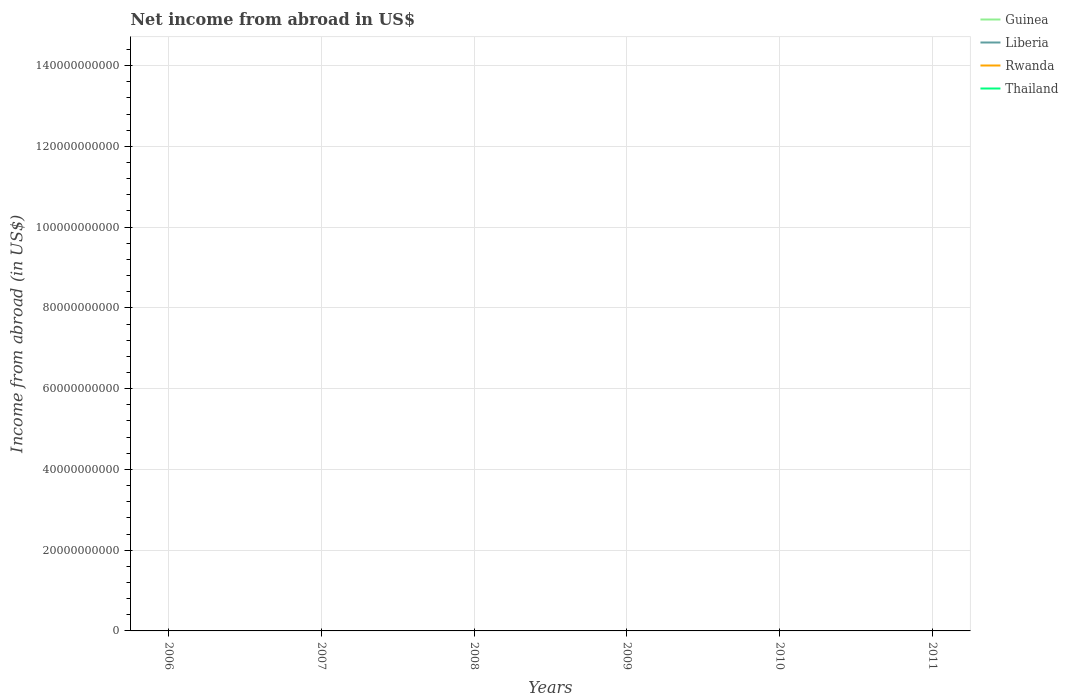How many different coloured lines are there?
Offer a terse response. 0. Does the line corresponding to Rwanda intersect with the line corresponding to Thailand?
Offer a very short reply. No. Is the number of lines equal to the number of legend labels?
Give a very brief answer. No. Across all years, what is the maximum net income from abroad in Thailand?
Offer a terse response. 0. Is the net income from abroad in Liberia strictly greater than the net income from abroad in Rwanda over the years?
Offer a terse response. No. What is the difference between two consecutive major ticks on the Y-axis?
Provide a short and direct response. 2.00e+1. Are the values on the major ticks of Y-axis written in scientific E-notation?
Your answer should be very brief. No. Where does the legend appear in the graph?
Make the answer very short. Top right. What is the title of the graph?
Ensure brevity in your answer.  Net income from abroad in US$. Does "Bahamas" appear as one of the legend labels in the graph?
Provide a succinct answer. No. What is the label or title of the X-axis?
Your response must be concise. Years. What is the label or title of the Y-axis?
Offer a terse response. Income from abroad (in US$). What is the Income from abroad (in US$) in Guinea in 2006?
Your answer should be very brief. 0. What is the Income from abroad (in US$) in Liberia in 2007?
Keep it short and to the point. 0. What is the Income from abroad (in US$) in Rwanda in 2007?
Give a very brief answer. 0. What is the Income from abroad (in US$) of Guinea in 2008?
Provide a short and direct response. 0. What is the Income from abroad (in US$) in Liberia in 2008?
Ensure brevity in your answer.  0. What is the Income from abroad (in US$) of Rwanda in 2008?
Your answer should be compact. 0. What is the Income from abroad (in US$) of Guinea in 2009?
Ensure brevity in your answer.  0. What is the Income from abroad (in US$) of Rwanda in 2009?
Ensure brevity in your answer.  0. What is the Income from abroad (in US$) in Thailand in 2009?
Your answer should be very brief. 0. What is the Income from abroad (in US$) in Guinea in 2011?
Ensure brevity in your answer.  0. What is the Income from abroad (in US$) in Rwanda in 2011?
Your answer should be compact. 0. What is the Income from abroad (in US$) in Thailand in 2011?
Provide a succinct answer. 0. What is the total Income from abroad (in US$) of Guinea in the graph?
Give a very brief answer. 0. What is the total Income from abroad (in US$) in Rwanda in the graph?
Offer a terse response. 0. What is the total Income from abroad (in US$) of Thailand in the graph?
Give a very brief answer. 0. What is the average Income from abroad (in US$) of Guinea per year?
Provide a succinct answer. 0. 